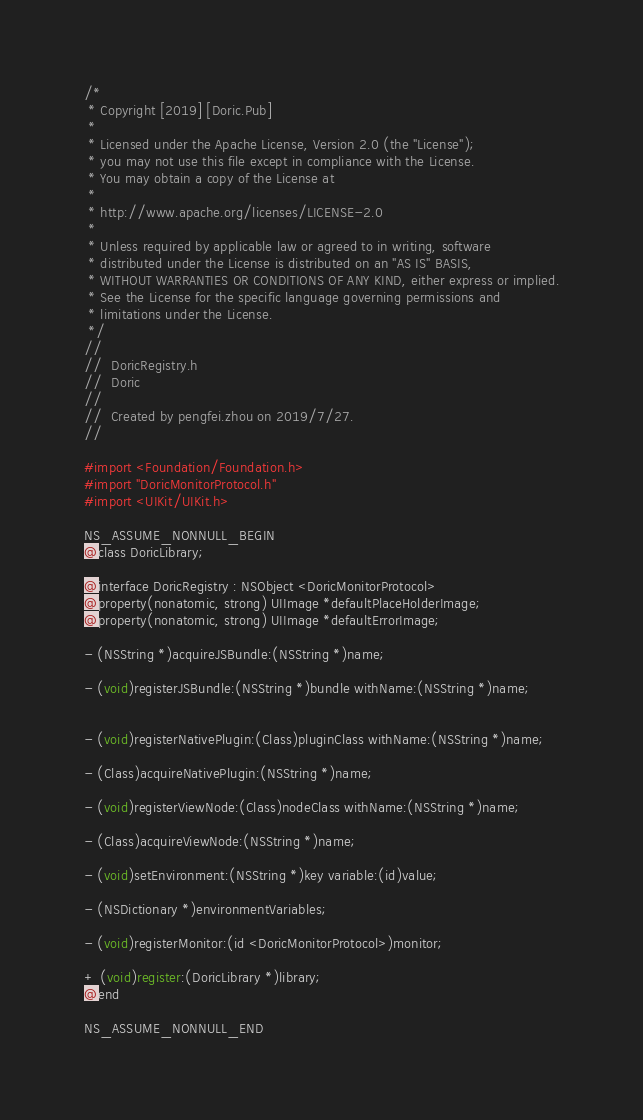<code> <loc_0><loc_0><loc_500><loc_500><_C_>/*
 * Copyright [2019] [Doric.Pub]
 *
 * Licensed under the Apache License, Version 2.0 (the "License");
 * you may not use this file except in compliance with the License.
 * You may obtain a copy of the License at
 *
 * http://www.apache.org/licenses/LICENSE-2.0
 *
 * Unless required by applicable law or agreed to in writing, software
 * distributed under the License is distributed on an "AS IS" BASIS,
 * WITHOUT WARRANTIES OR CONDITIONS OF ANY KIND, either express or implied.
 * See the License for the specific language governing permissions and
 * limitations under the License.
 */
//
//  DoricRegistry.h
//  Doric
//
//  Created by pengfei.zhou on 2019/7/27.
//

#import <Foundation/Foundation.h>
#import "DoricMonitorProtocol.h"
#import <UIKit/UIKit.h>

NS_ASSUME_NONNULL_BEGIN
@class DoricLibrary;

@interface DoricRegistry : NSObject <DoricMonitorProtocol>
@property(nonatomic, strong) UIImage *defaultPlaceHolderImage;
@property(nonatomic, strong) UIImage *defaultErrorImage;

- (NSString *)acquireJSBundle:(NSString *)name;

- (void)registerJSBundle:(NSString *)bundle withName:(NSString *)name;


- (void)registerNativePlugin:(Class)pluginClass withName:(NSString *)name;

- (Class)acquireNativePlugin:(NSString *)name;

- (void)registerViewNode:(Class)nodeClass withName:(NSString *)name;

- (Class)acquireViewNode:(NSString *)name;

- (void)setEnvironment:(NSString *)key variable:(id)value;

- (NSDictionary *)environmentVariables;

- (void)registerMonitor:(id <DoricMonitorProtocol>)monitor;

+ (void)register:(DoricLibrary *)library;
@end

NS_ASSUME_NONNULL_END
</code> 